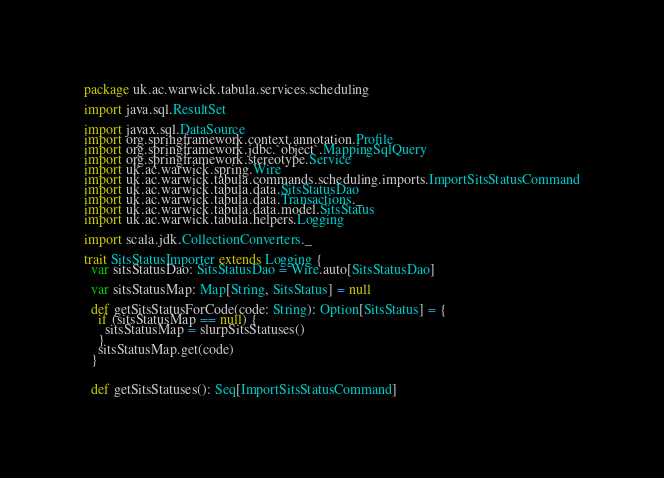<code> <loc_0><loc_0><loc_500><loc_500><_Scala_>package uk.ac.warwick.tabula.services.scheduling

import java.sql.ResultSet

import javax.sql.DataSource
import org.springframework.context.annotation.Profile
import org.springframework.jdbc.`object`.MappingSqlQuery
import org.springframework.stereotype.Service
import uk.ac.warwick.spring.Wire
import uk.ac.warwick.tabula.commands.scheduling.imports.ImportSitsStatusCommand
import uk.ac.warwick.tabula.data.SitsStatusDao
import uk.ac.warwick.tabula.data.Transactions._
import uk.ac.warwick.tabula.data.model.SitsStatus
import uk.ac.warwick.tabula.helpers.Logging

import scala.jdk.CollectionConverters._

trait SitsStatusImporter extends Logging {
  var sitsStatusDao: SitsStatusDao = Wire.auto[SitsStatusDao]

  var sitsStatusMap: Map[String, SitsStatus] = null

  def getSitsStatusForCode(code: String): Option[SitsStatus] = {
    if (sitsStatusMap == null) {
      sitsStatusMap = slurpSitsStatuses()
    }
    sitsStatusMap.get(code)
  }


  def getSitsStatuses(): Seq[ImportSitsStatusCommand]
</code> 